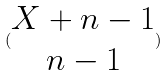<formula> <loc_0><loc_0><loc_500><loc_500>( \begin{matrix} X + n - 1 \\ n - 1 \end{matrix} )</formula> 